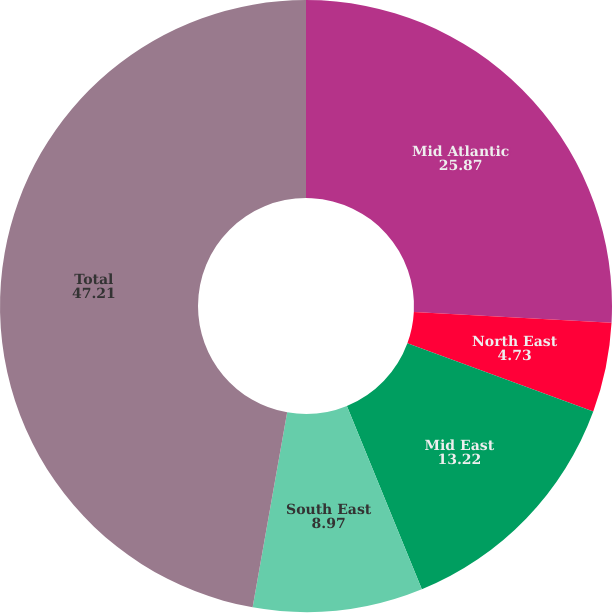<chart> <loc_0><loc_0><loc_500><loc_500><pie_chart><fcel>Mid Atlantic<fcel>North East<fcel>Mid East<fcel>South East<fcel>Total<nl><fcel>25.87%<fcel>4.73%<fcel>13.22%<fcel>8.97%<fcel>47.21%<nl></chart> 